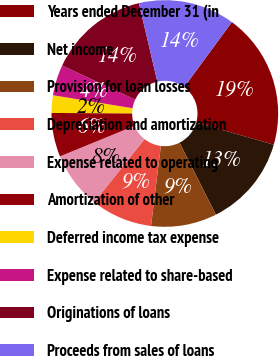Convert chart. <chart><loc_0><loc_0><loc_500><loc_500><pie_chart><fcel>Years ended December 31 (in<fcel>Net income<fcel>Provision for loan losses<fcel>Depreciation and amortization<fcel>Expense related to operating<fcel>Amortization of other<fcel>Deferred income tax expense<fcel>Expense related to share-based<fcel>Originations of loans<fcel>Proceeds from sales of loans<nl><fcel>19.37%<fcel>13.12%<fcel>9.38%<fcel>8.75%<fcel>8.13%<fcel>6.25%<fcel>2.5%<fcel>4.38%<fcel>14.37%<fcel>13.75%<nl></chart> 